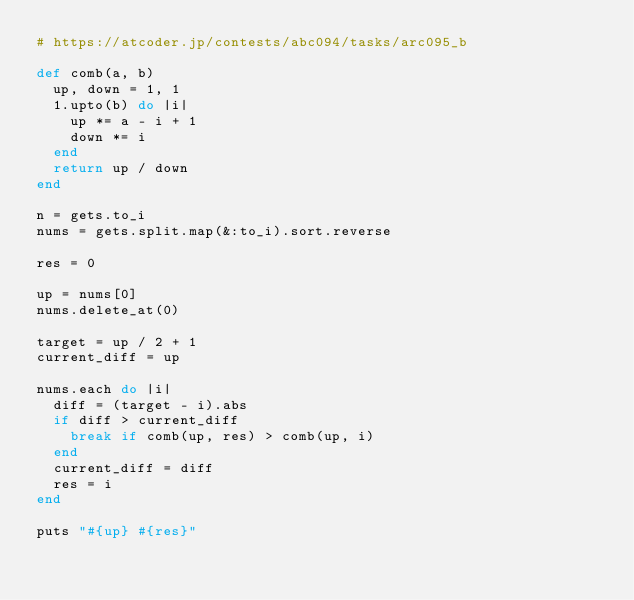<code> <loc_0><loc_0><loc_500><loc_500><_Ruby_># https://atcoder.jp/contests/abc094/tasks/arc095_b

def comb(a, b)
  up, down = 1, 1
  1.upto(b) do |i|
    up *= a - i + 1
    down *= i
  end
  return up / down
end

n = gets.to_i
nums = gets.split.map(&:to_i).sort.reverse

res = 0

up = nums[0]
nums.delete_at(0)

target = up / 2 + 1
current_diff = up

nums.each do |i|
  diff = (target - i).abs
  if diff > current_diff
    break if comb(up, res) > comb(up, i)
  end
  current_diff = diff
  res = i
end

puts "#{up} #{res}"</code> 